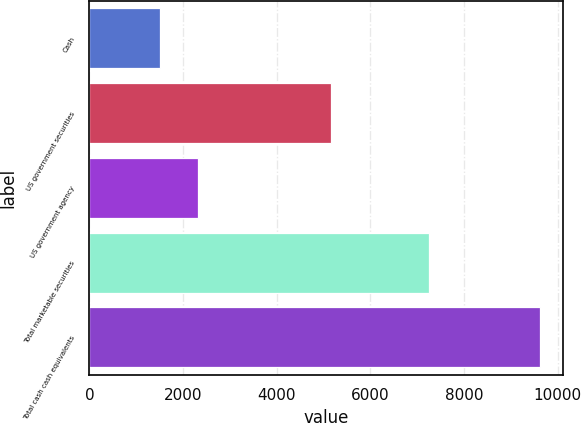<chart> <loc_0><loc_0><loc_500><loc_500><bar_chart><fcel>Cash<fcel>US government securities<fcel>US government agency<fcel>Total marketable securities<fcel>Total cash cash equivalents<nl><fcel>1513<fcel>5165<fcel>2324.3<fcel>7242<fcel>9626<nl></chart> 